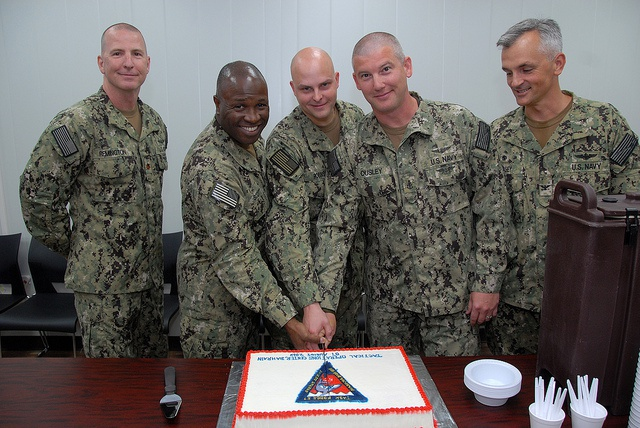Describe the objects in this image and their specific colors. I can see people in darkgray, gray, and black tones, people in darkgray, gray, and black tones, people in darkgray, gray, black, and maroon tones, people in darkgray, gray, black, and maroon tones, and dining table in darkgray, maroon, black, lavender, and gray tones in this image. 